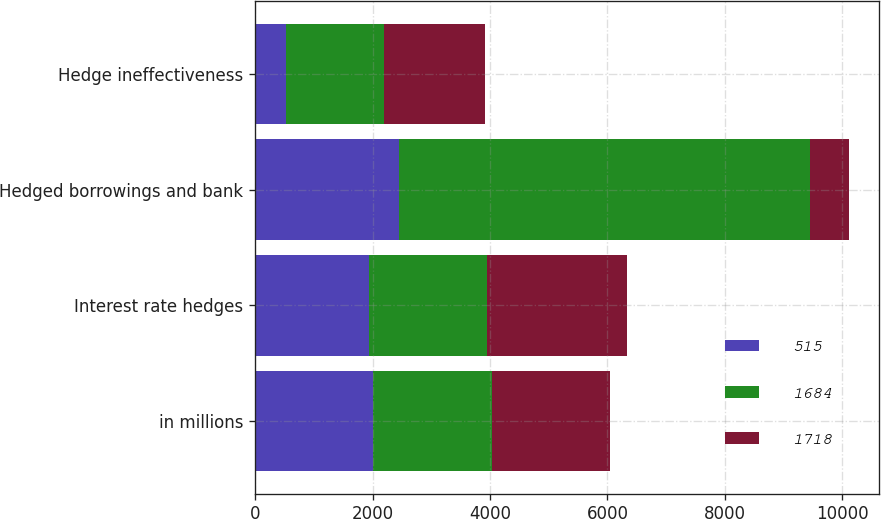Convert chart. <chart><loc_0><loc_0><loc_500><loc_500><stacked_bar_chart><ecel><fcel>in millions<fcel>Interest rate hedges<fcel>Hedged borrowings and bank<fcel>Hedge ineffectiveness<nl><fcel>515<fcel>2014<fcel>1936<fcel>2451<fcel>515<nl><fcel>1684<fcel>2013<fcel>2012<fcel>6999<fcel>1684<nl><fcel>1718<fcel>2012<fcel>2383<fcel>665<fcel>1718<nl></chart> 